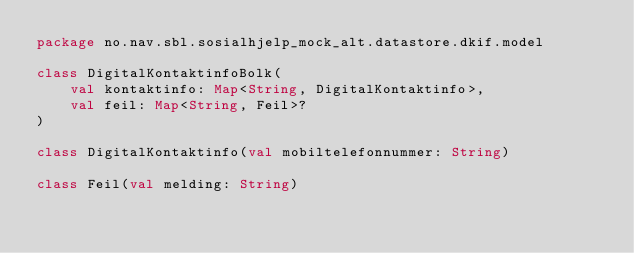<code> <loc_0><loc_0><loc_500><loc_500><_Kotlin_>package no.nav.sbl.sosialhjelp_mock_alt.datastore.dkif.model

class DigitalKontaktinfoBolk(
    val kontaktinfo: Map<String, DigitalKontaktinfo>,
    val feil: Map<String, Feil>?
)

class DigitalKontaktinfo(val mobiltelefonnummer: String)

class Feil(val melding: String)
</code> 